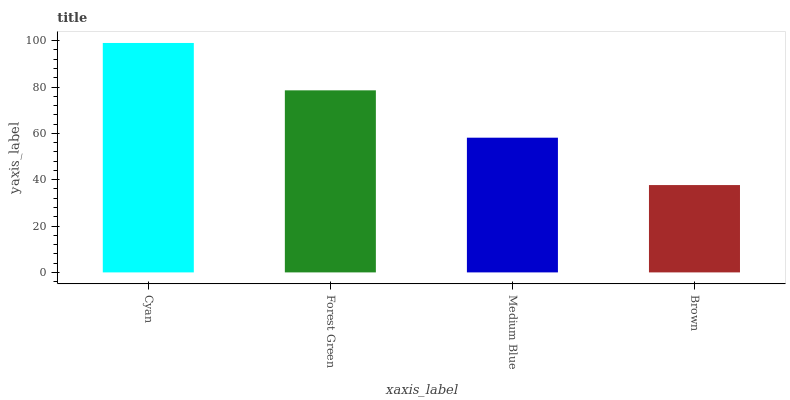Is Brown the minimum?
Answer yes or no. Yes. Is Cyan the maximum?
Answer yes or no. Yes. Is Forest Green the minimum?
Answer yes or no. No. Is Forest Green the maximum?
Answer yes or no. No. Is Cyan greater than Forest Green?
Answer yes or no. Yes. Is Forest Green less than Cyan?
Answer yes or no. Yes. Is Forest Green greater than Cyan?
Answer yes or no. No. Is Cyan less than Forest Green?
Answer yes or no. No. Is Forest Green the high median?
Answer yes or no. Yes. Is Medium Blue the low median?
Answer yes or no. Yes. Is Medium Blue the high median?
Answer yes or no. No. Is Cyan the low median?
Answer yes or no. No. 